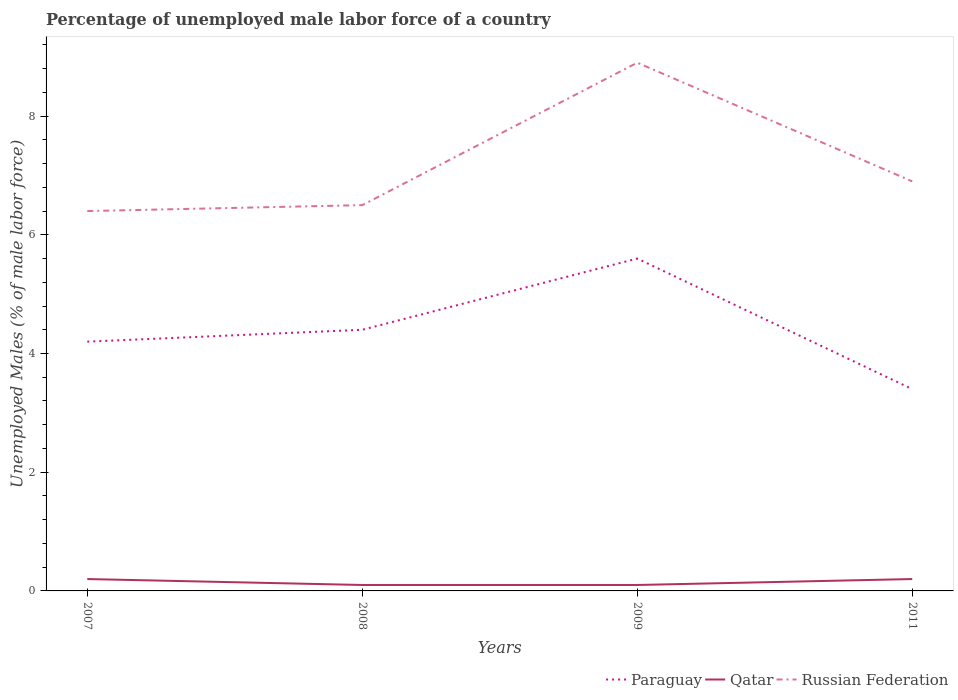Across all years, what is the maximum percentage of unemployed male labor force in Russian Federation?
Keep it short and to the point. 6.4. What is the total percentage of unemployed male labor force in Russian Federation in the graph?
Provide a succinct answer. -2.4. What is the difference between the highest and the second highest percentage of unemployed male labor force in Russian Federation?
Make the answer very short. 2.5. How many lines are there?
Provide a succinct answer. 3. Where does the legend appear in the graph?
Provide a succinct answer. Bottom right. How many legend labels are there?
Your response must be concise. 3. What is the title of the graph?
Your answer should be very brief. Percentage of unemployed male labor force of a country. Does "Greece" appear as one of the legend labels in the graph?
Offer a terse response. No. What is the label or title of the X-axis?
Offer a very short reply. Years. What is the label or title of the Y-axis?
Offer a terse response. Unemployed Males (% of male labor force). What is the Unemployed Males (% of male labor force) in Paraguay in 2007?
Offer a very short reply. 4.2. What is the Unemployed Males (% of male labor force) in Qatar in 2007?
Provide a succinct answer. 0.2. What is the Unemployed Males (% of male labor force) in Russian Federation in 2007?
Your answer should be compact. 6.4. What is the Unemployed Males (% of male labor force) of Paraguay in 2008?
Offer a very short reply. 4.4. What is the Unemployed Males (% of male labor force) of Qatar in 2008?
Offer a terse response. 0.1. What is the Unemployed Males (% of male labor force) in Paraguay in 2009?
Provide a short and direct response. 5.6. What is the Unemployed Males (% of male labor force) of Qatar in 2009?
Offer a terse response. 0.1. What is the Unemployed Males (% of male labor force) in Russian Federation in 2009?
Keep it short and to the point. 8.9. What is the Unemployed Males (% of male labor force) of Paraguay in 2011?
Offer a very short reply. 3.4. What is the Unemployed Males (% of male labor force) in Qatar in 2011?
Offer a terse response. 0.2. What is the Unemployed Males (% of male labor force) of Russian Federation in 2011?
Keep it short and to the point. 6.9. Across all years, what is the maximum Unemployed Males (% of male labor force) of Paraguay?
Keep it short and to the point. 5.6. Across all years, what is the maximum Unemployed Males (% of male labor force) in Qatar?
Offer a very short reply. 0.2. Across all years, what is the maximum Unemployed Males (% of male labor force) in Russian Federation?
Your answer should be very brief. 8.9. Across all years, what is the minimum Unemployed Males (% of male labor force) in Paraguay?
Your answer should be very brief. 3.4. Across all years, what is the minimum Unemployed Males (% of male labor force) in Qatar?
Offer a very short reply. 0.1. Across all years, what is the minimum Unemployed Males (% of male labor force) of Russian Federation?
Keep it short and to the point. 6.4. What is the total Unemployed Males (% of male labor force) in Qatar in the graph?
Ensure brevity in your answer.  0.6. What is the total Unemployed Males (% of male labor force) in Russian Federation in the graph?
Your response must be concise. 28.7. What is the difference between the Unemployed Males (% of male labor force) of Paraguay in 2007 and that in 2008?
Offer a terse response. -0.2. What is the difference between the Unemployed Males (% of male labor force) of Paraguay in 2007 and that in 2009?
Offer a very short reply. -1.4. What is the difference between the Unemployed Males (% of male labor force) in Qatar in 2007 and that in 2009?
Provide a short and direct response. 0.1. What is the difference between the Unemployed Males (% of male labor force) in Russian Federation in 2007 and that in 2009?
Give a very brief answer. -2.5. What is the difference between the Unemployed Males (% of male labor force) in Paraguay in 2007 and that in 2011?
Your answer should be very brief. 0.8. What is the difference between the Unemployed Males (% of male labor force) of Qatar in 2007 and that in 2011?
Provide a succinct answer. 0. What is the difference between the Unemployed Males (% of male labor force) of Qatar in 2008 and that in 2009?
Your answer should be compact. 0. What is the difference between the Unemployed Males (% of male labor force) of Paraguay in 2009 and that in 2011?
Offer a very short reply. 2.2. What is the difference between the Unemployed Males (% of male labor force) in Paraguay in 2007 and the Unemployed Males (% of male labor force) in Qatar in 2008?
Ensure brevity in your answer.  4.1. What is the difference between the Unemployed Males (% of male labor force) of Qatar in 2007 and the Unemployed Males (% of male labor force) of Russian Federation in 2008?
Provide a short and direct response. -6.3. What is the difference between the Unemployed Males (% of male labor force) of Paraguay in 2007 and the Unemployed Males (% of male labor force) of Qatar in 2011?
Make the answer very short. 4. What is the difference between the Unemployed Males (% of male labor force) of Paraguay in 2008 and the Unemployed Males (% of male labor force) of Russian Federation in 2009?
Your answer should be very brief. -4.5. What is the difference between the Unemployed Males (% of male labor force) in Paraguay in 2008 and the Unemployed Males (% of male labor force) in Russian Federation in 2011?
Ensure brevity in your answer.  -2.5. What is the average Unemployed Males (% of male labor force) in Paraguay per year?
Provide a succinct answer. 4.4. What is the average Unemployed Males (% of male labor force) of Russian Federation per year?
Offer a terse response. 7.17. In the year 2007, what is the difference between the Unemployed Males (% of male labor force) of Paraguay and Unemployed Males (% of male labor force) of Qatar?
Provide a short and direct response. 4. In the year 2007, what is the difference between the Unemployed Males (% of male labor force) in Paraguay and Unemployed Males (% of male labor force) in Russian Federation?
Offer a very short reply. -2.2. In the year 2007, what is the difference between the Unemployed Males (% of male labor force) in Qatar and Unemployed Males (% of male labor force) in Russian Federation?
Provide a succinct answer. -6.2. In the year 2008, what is the difference between the Unemployed Males (% of male labor force) in Qatar and Unemployed Males (% of male labor force) in Russian Federation?
Give a very brief answer. -6.4. In the year 2009, what is the difference between the Unemployed Males (% of male labor force) of Paraguay and Unemployed Males (% of male labor force) of Russian Federation?
Ensure brevity in your answer.  -3.3. In the year 2011, what is the difference between the Unemployed Males (% of male labor force) in Paraguay and Unemployed Males (% of male labor force) in Qatar?
Offer a very short reply. 3.2. What is the ratio of the Unemployed Males (% of male labor force) in Paraguay in 2007 to that in 2008?
Give a very brief answer. 0.95. What is the ratio of the Unemployed Males (% of male labor force) of Qatar in 2007 to that in 2008?
Offer a terse response. 2. What is the ratio of the Unemployed Males (% of male labor force) in Russian Federation in 2007 to that in 2008?
Give a very brief answer. 0.98. What is the ratio of the Unemployed Males (% of male labor force) of Paraguay in 2007 to that in 2009?
Give a very brief answer. 0.75. What is the ratio of the Unemployed Males (% of male labor force) of Russian Federation in 2007 to that in 2009?
Ensure brevity in your answer.  0.72. What is the ratio of the Unemployed Males (% of male labor force) of Paraguay in 2007 to that in 2011?
Your answer should be compact. 1.24. What is the ratio of the Unemployed Males (% of male labor force) in Russian Federation in 2007 to that in 2011?
Offer a very short reply. 0.93. What is the ratio of the Unemployed Males (% of male labor force) of Paraguay in 2008 to that in 2009?
Your answer should be very brief. 0.79. What is the ratio of the Unemployed Males (% of male labor force) of Russian Federation in 2008 to that in 2009?
Offer a terse response. 0.73. What is the ratio of the Unemployed Males (% of male labor force) in Paraguay in 2008 to that in 2011?
Ensure brevity in your answer.  1.29. What is the ratio of the Unemployed Males (% of male labor force) of Russian Federation in 2008 to that in 2011?
Keep it short and to the point. 0.94. What is the ratio of the Unemployed Males (% of male labor force) of Paraguay in 2009 to that in 2011?
Provide a succinct answer. 1.65. What is the ratio of the Unemployed Males (% of male labor force) of Qatar in 2009 to that in 2011?
Offer a terse response. 0.5. What is the ratio of the Unemployed Males (% of male labor force) in Russian Federation in 2009 to that in 2011?
Offer a very short reply. 1.29. What is the difference between the highest and the second highest Unemployed Males (% of male labor force) of Paraguay?
Offer a very short reply. 1.2. What is the difference between the highest and the second highest Unemployed Males (% of male labor force) of Russian Federation?
Your response must be concise. 2. What is the difference between the highest and the lowest Unemployed Males (% of male labor force) in Paraguay?
Provide a succinct answer. 2.2. What is the difference between the highest and the lowest Unemployed Males (% of male labor force) in Qatar?
Give a very brief answer. 0.1. 